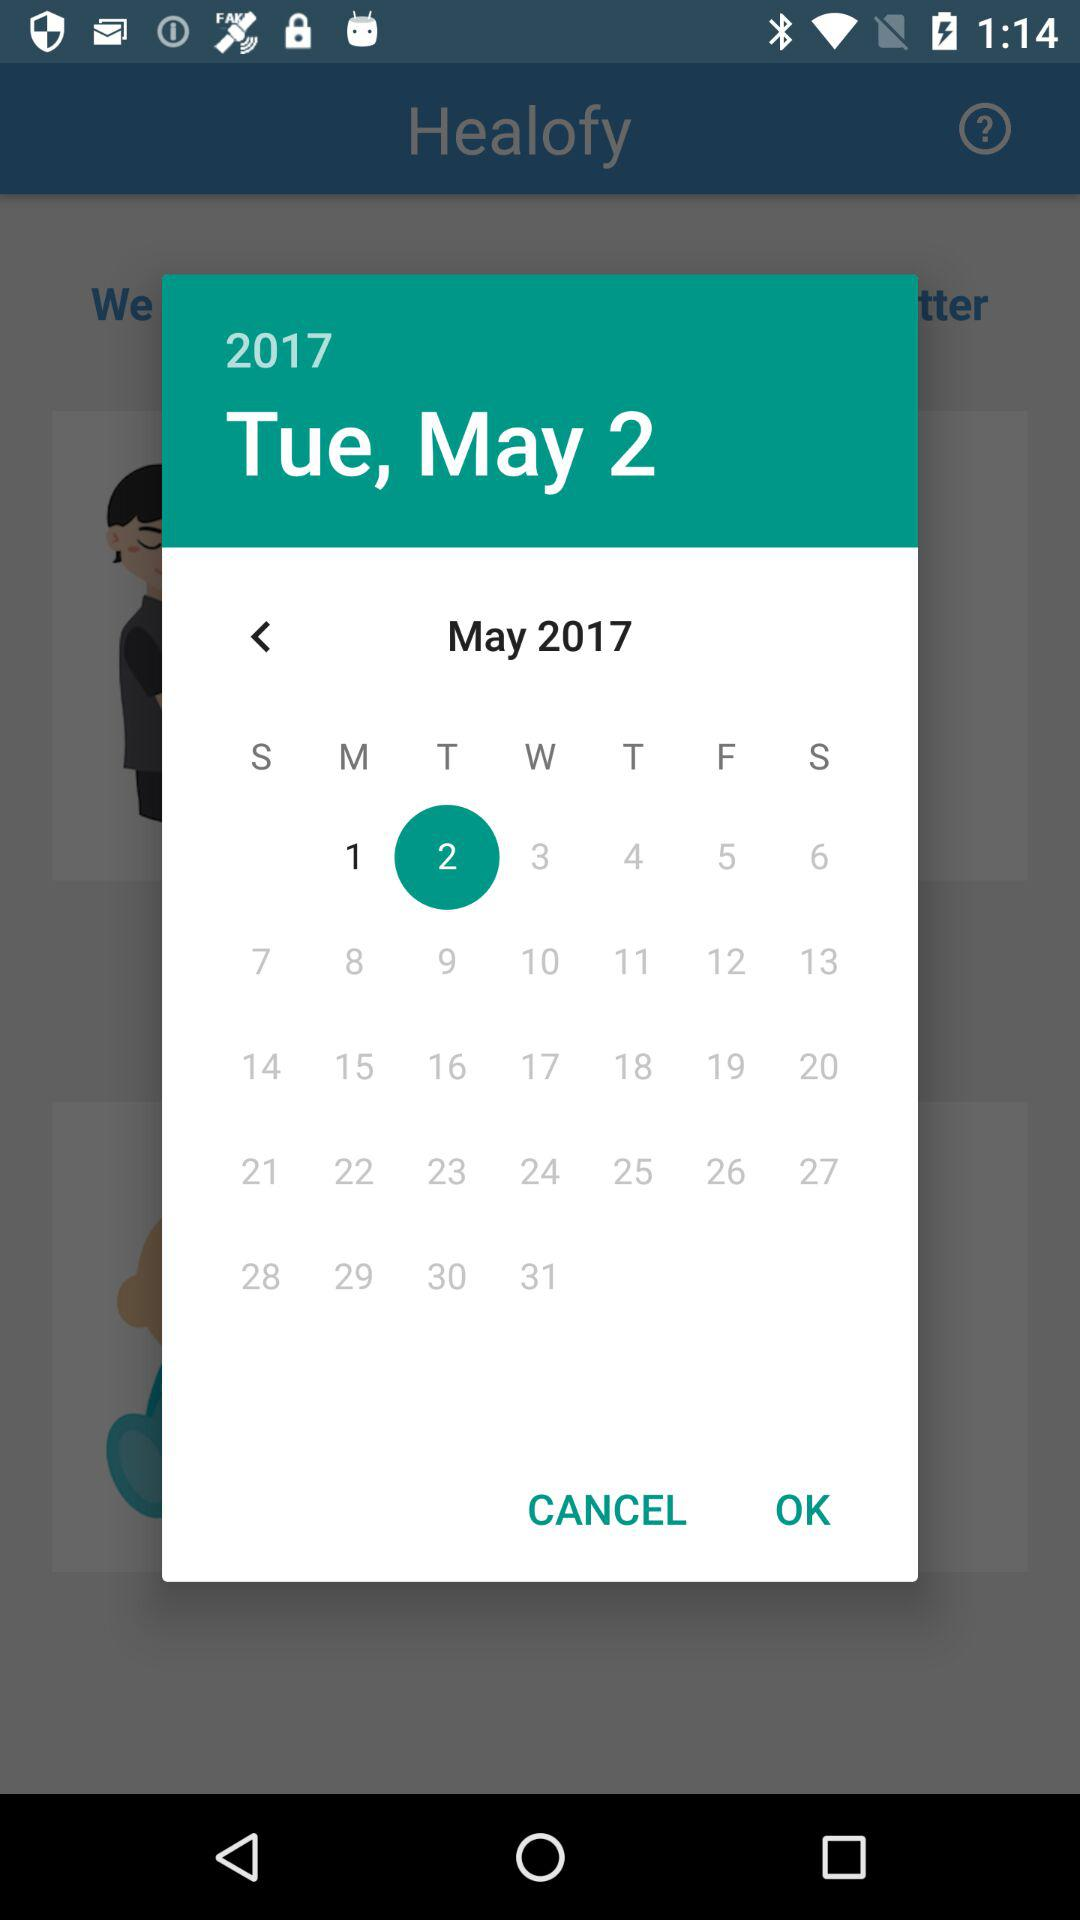Which date is selected in the calendar? The selected date in the calendar is Tuesday, May 2, 2017. 